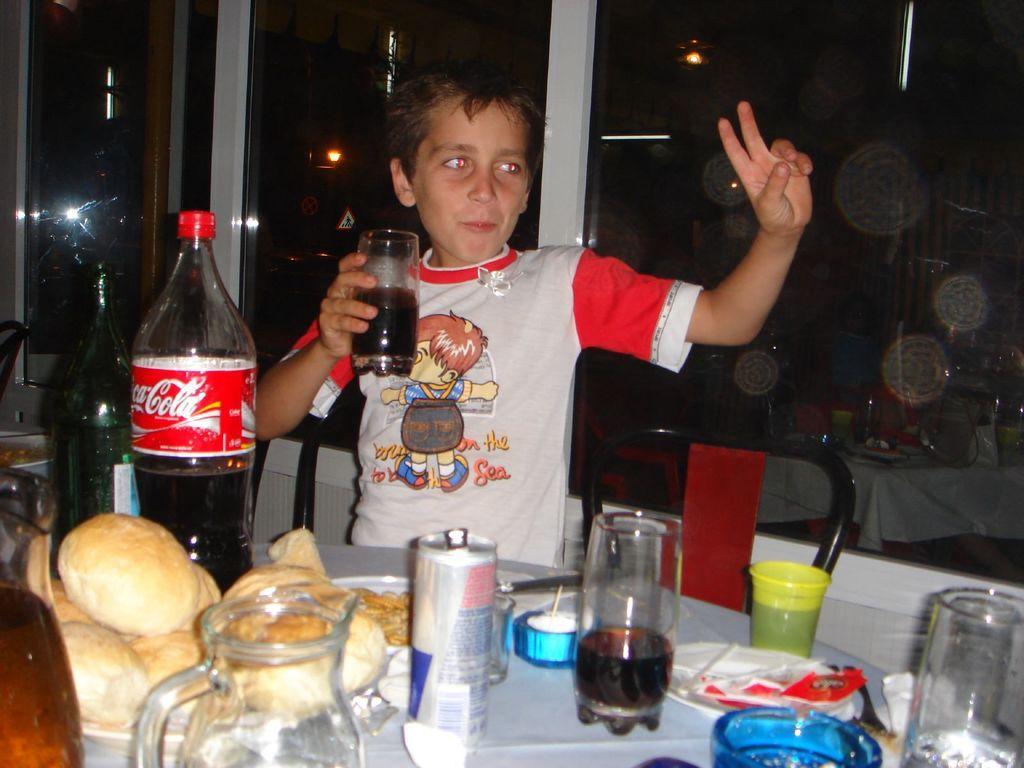How would you summarize this image in a sentence or two? There is a boy in this picture holding a glass in his hands. He is standing. In front of him there is a table on which some food items, glass jars, tins and some plates along with some bottles were placed. In the background, there is a glass here. 